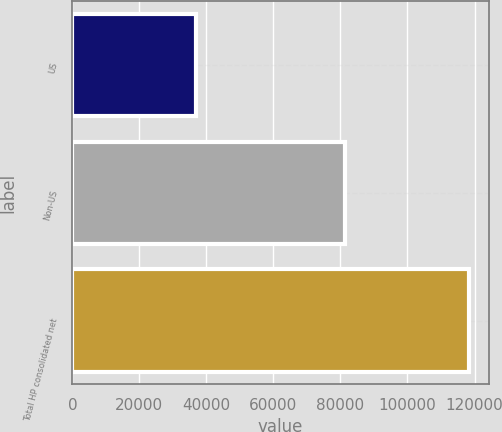Convert chart to OTSL. <chart><loc_0><loc_0><loc_500><loc_500><bar_chart><fcel>US<fcel>Non-US<fcel>Total HP consolidated net<nl><fcel>36932<fcel>81432<fcel>118364<nl></chart> 